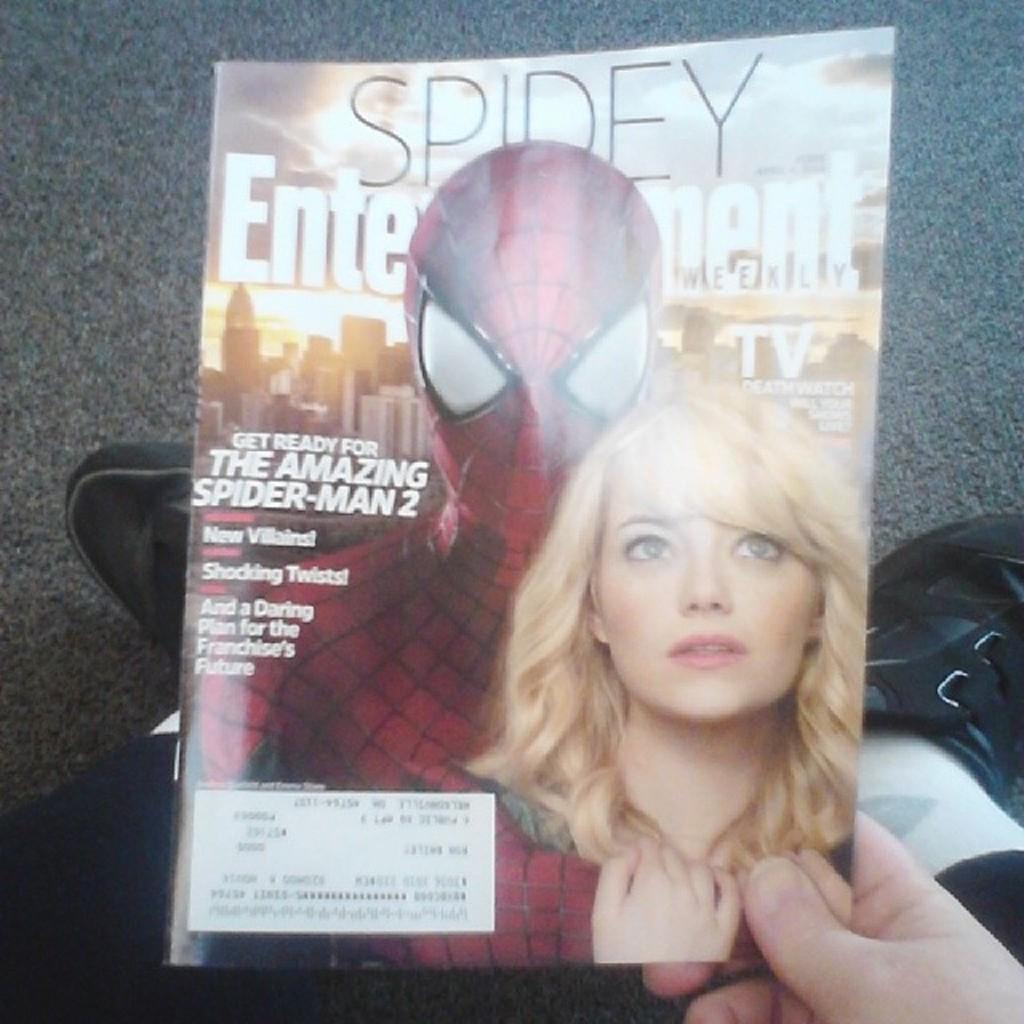Please provide a concise description of this image. On the left side, there is a leg of a person who is wearing a shoe. On the right side, there is a hand of a person who is holding a magazine. Behind this magazine, there is a leg of the person who is wearing a shoe which is on a carpet. And the background is gray in color. 